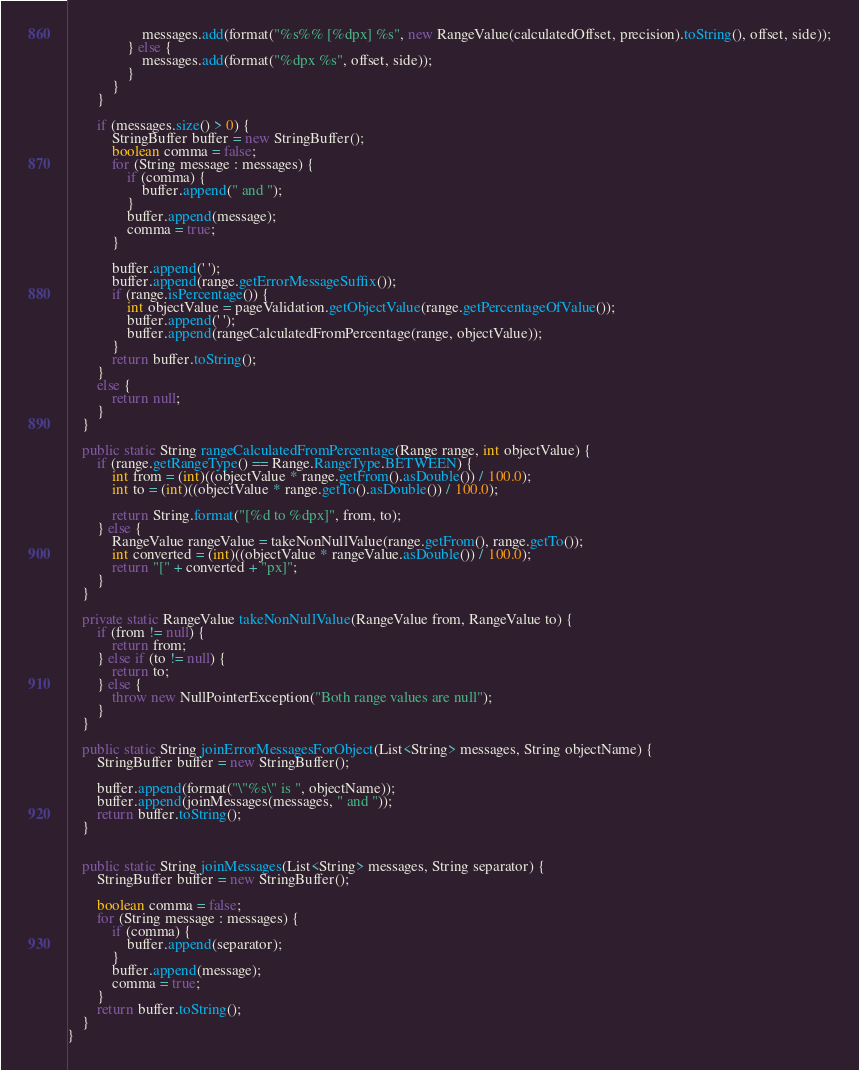Convert code to text. <code><loc_0><loc_0><loc_500><loc_500><_Java_>                    messages.add(format("%s%% [%dpx] %s", new RangeValue(calculatedOffset, precision).toString(), offset, side));
                } else {
                    messages.add(format("%dpx %s", offset, side));
                }
            }
        }

        if (messages.size() > 0) {
            StringBuffer buffer = new StringBuffer();
            boolean comma = false;
            for (String message : messages) {
                if (comma) {
                    buffer.append(" and ");
                }
                buffer.append(message);
                comma = true;
            }

            buffer.append(' ');
            buffer.append(range.getErrorMessageSuffix());
            if (range.isPercentage()) {
                int objectValue = pageValidation.getObjectValue(range.getPercentageOfValue());
                buffer.append(' ');
                buffer.append(rangeCalculatedFromPercentage(range, objectValue));
            }
            return buffer.toString();
        }
        else {
            return null;
        }
    }

    public static String rangeCalculatedFromPercentage(Range range, int objectValue) {
        if (range.getRangeType() == Range.RangeType.BETWEEN) {
            int from = (int)((objectValue * range.getFrom().asDouble()) / 100.0);
            int to = (int)((objectValue * range.getTo().asDouble()) / 100.0);

            return String.format("[%d to %dpx]", from, to);
        } else {
            RangeValue rangeValue = takeNonNullValue(range.getFrom(), range.getTo());
            int converted = (int)((objectValue * rangeValue.asDouble()) / 100.0);
            return "[" + converted + "px]";
        }
    }

    private static RangeValue takeNonNullValue(RangeValue from, RangeValue to) {
        if (from != null) {
            return from;
        } else if (to != null) {
            return to;
        } else {
            throw new NullPointerException("Both range values are null");
        }
    }

    public static String joinErrorMessagesForObject(List<String> messages, String objectName) {
        StringBuffer buffer = new StringBuffer();

        buffer.append(format("\"%s\" is ", objectName));
        buffer.append(joinMessages(messages, " and "));
        return buffer.toString();
    }


    public static String joinMessages(List<String> messages, String separator) {
        StringBuffer buffer = new StringBuffer();

        boolean comma = false;
        for (String message : messages) {
            if (comma) {
                buffer.append(separator);
            }
            buffer.append(message);
            comma = true;
        }
        return buffer.toString();
    }
}
</code> 